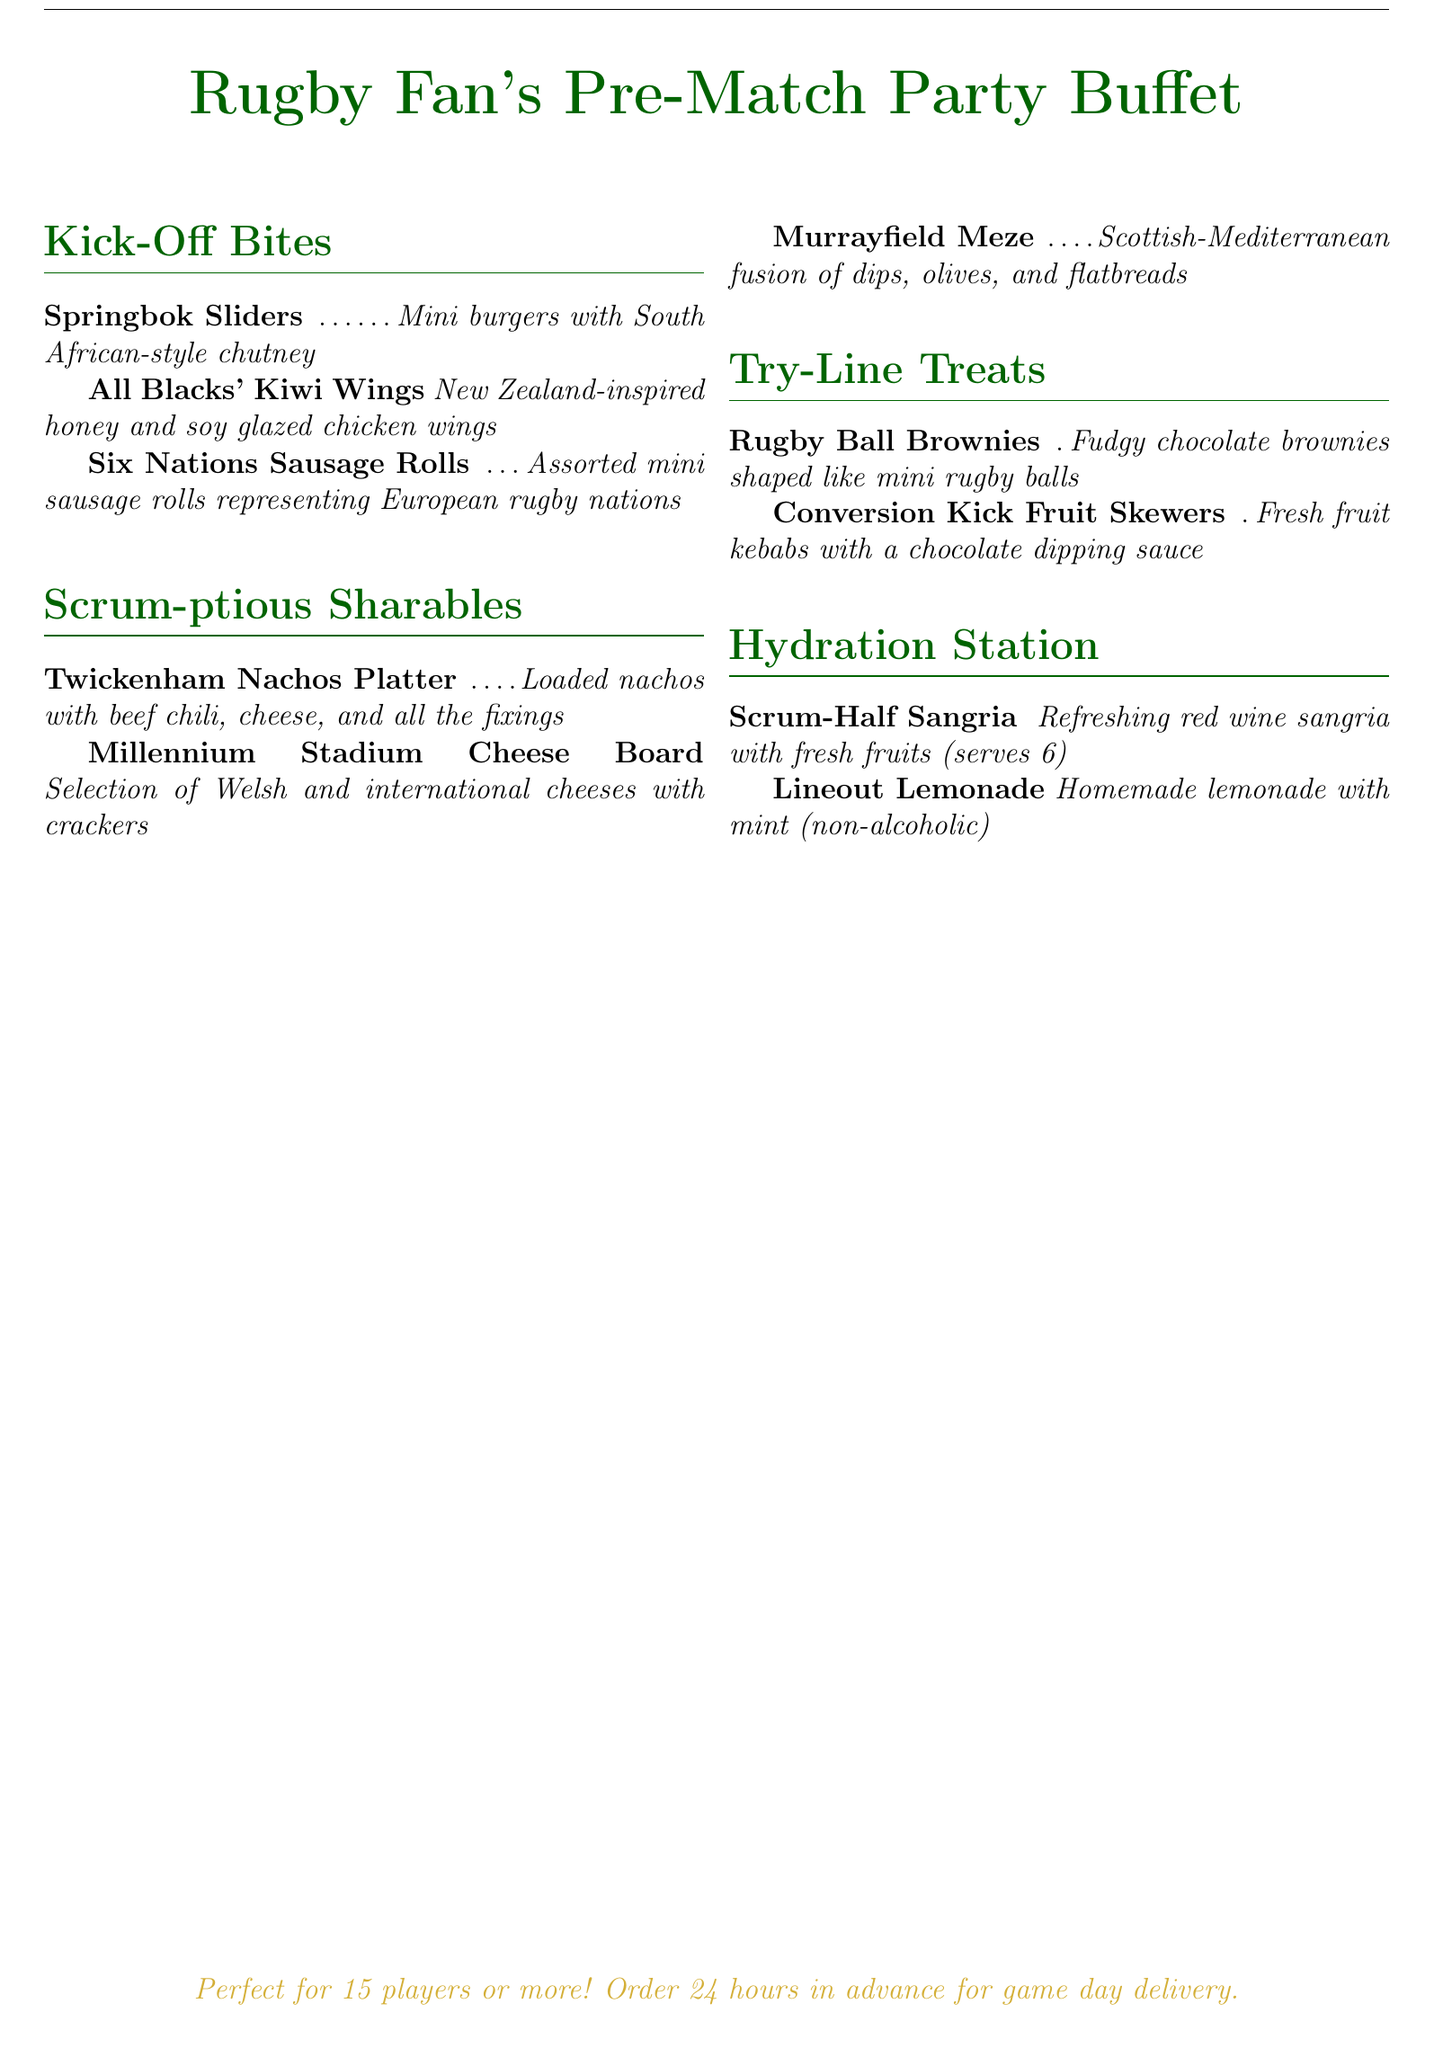What is the title of the menu? The title of the menu is prominently displayed at the top of the document and reads "Rugby Fan's Pre-Match Party Buffet."
Answer: Rugby Fan's Pre-Match Party Buffet How many types of "Kick-Off Bites" are listed? The menu lists three types of "Kick-Off Bites," which are different snack options available before the match.
Answer: 3 What item is part of the "Scrum-ptious Sharables"? The menu includes multiple items under "Scrum-ptious Sharables," one example is "Twickenham Nachos Platter."
Answer: Twickenham Nachos Platter What is the main fruit used in the "Lineout Lemonade"? The ingredients for "Lineout Lemonade" include mint and lemon.
Answer: Lemon What is the recommended minimum number of guests for the buffet? The document specifies that the buffet is "Perfect for 15 players or more!" indicating the minimum number of guests.
Answer: 15 What type of drink is served in the "Hydration Station"? The menu categorizes drinks under "Hydration Station," with examples like "Scrum-Half Sangria."
Answer: Sangria How many hours in advance should the order be placed? The document states that orders should be placed "24 hours in advance for game day delivery."
Answer: 24 hours Which dessert is shaped like a rugby ball? The menu specifies a dessert item that is shaped like a rugby ball is "Rugby Ball Brownies."
Answer: Rugby Ball Brownies What type of cuisine is represented by the "Murrayfield Meze"? "Murrayfield Meze" represents a Scottish-Mediterranean fusion, reflecting the culinary inspiration behind the dish.
Answer: Scottish-Mediterranean 